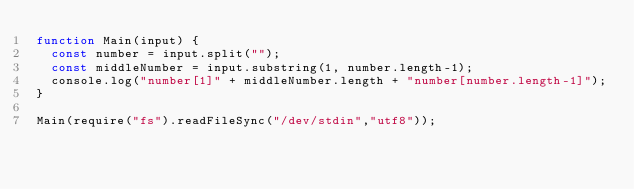<code> <loc_0><loc_0><loc_500><loc_500><_JavaScript_>function Main(input) {
  const number = input.split("");
  const middleNumber = input.substring(1, number.length-1);
  console.log("number[1]" + middleNumber.length + "number[number.length-1]");
}

Main(require("fs").readFileSync("/dev/stdin","utf8"));
</code> 